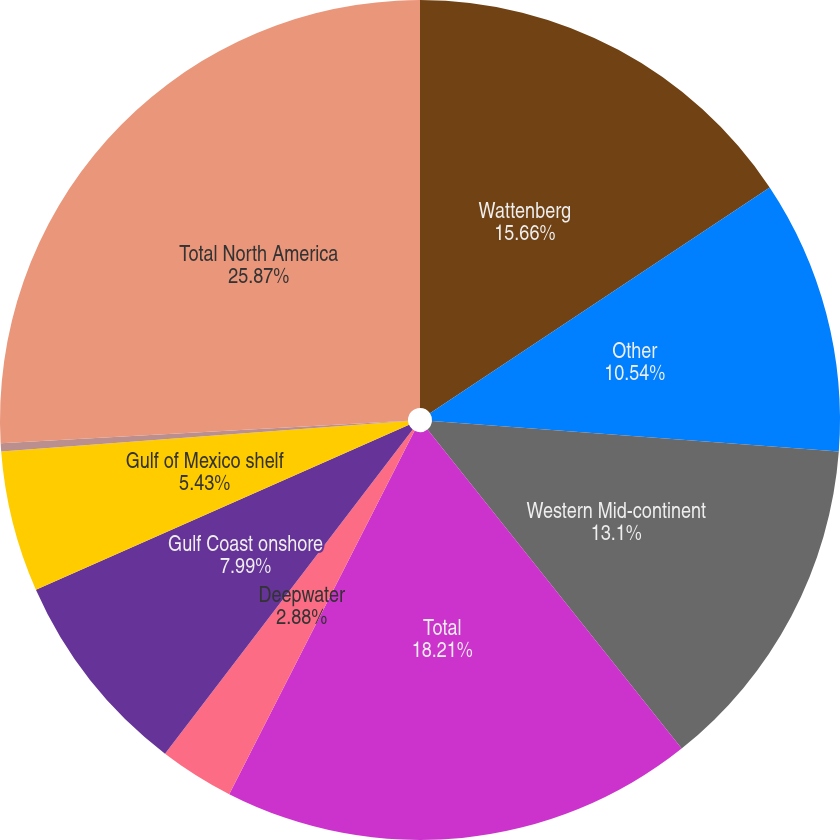Convert chart to OTSL. <chart><loc_0><loc_0><loc_500><loc_500><pie_chart><fcel>Wattenberg<fcel>Other<fcel>Western Mid-continent<fcel>Total<fcel>Deepwater<fcel>Gulf Coast onshore<fcel>Gulf of Mexico shelf<fcel>Eastern Mid-continent<fcel>Total North America<nl><fcel>15.66%<fcel>10.54%<fcel>13.1%<fcel>18.21%<fcel>2.88%<fcel>7.99%<fcel>5.43%<fcel>0.32%<fcel>25.88%<nl></chart> 